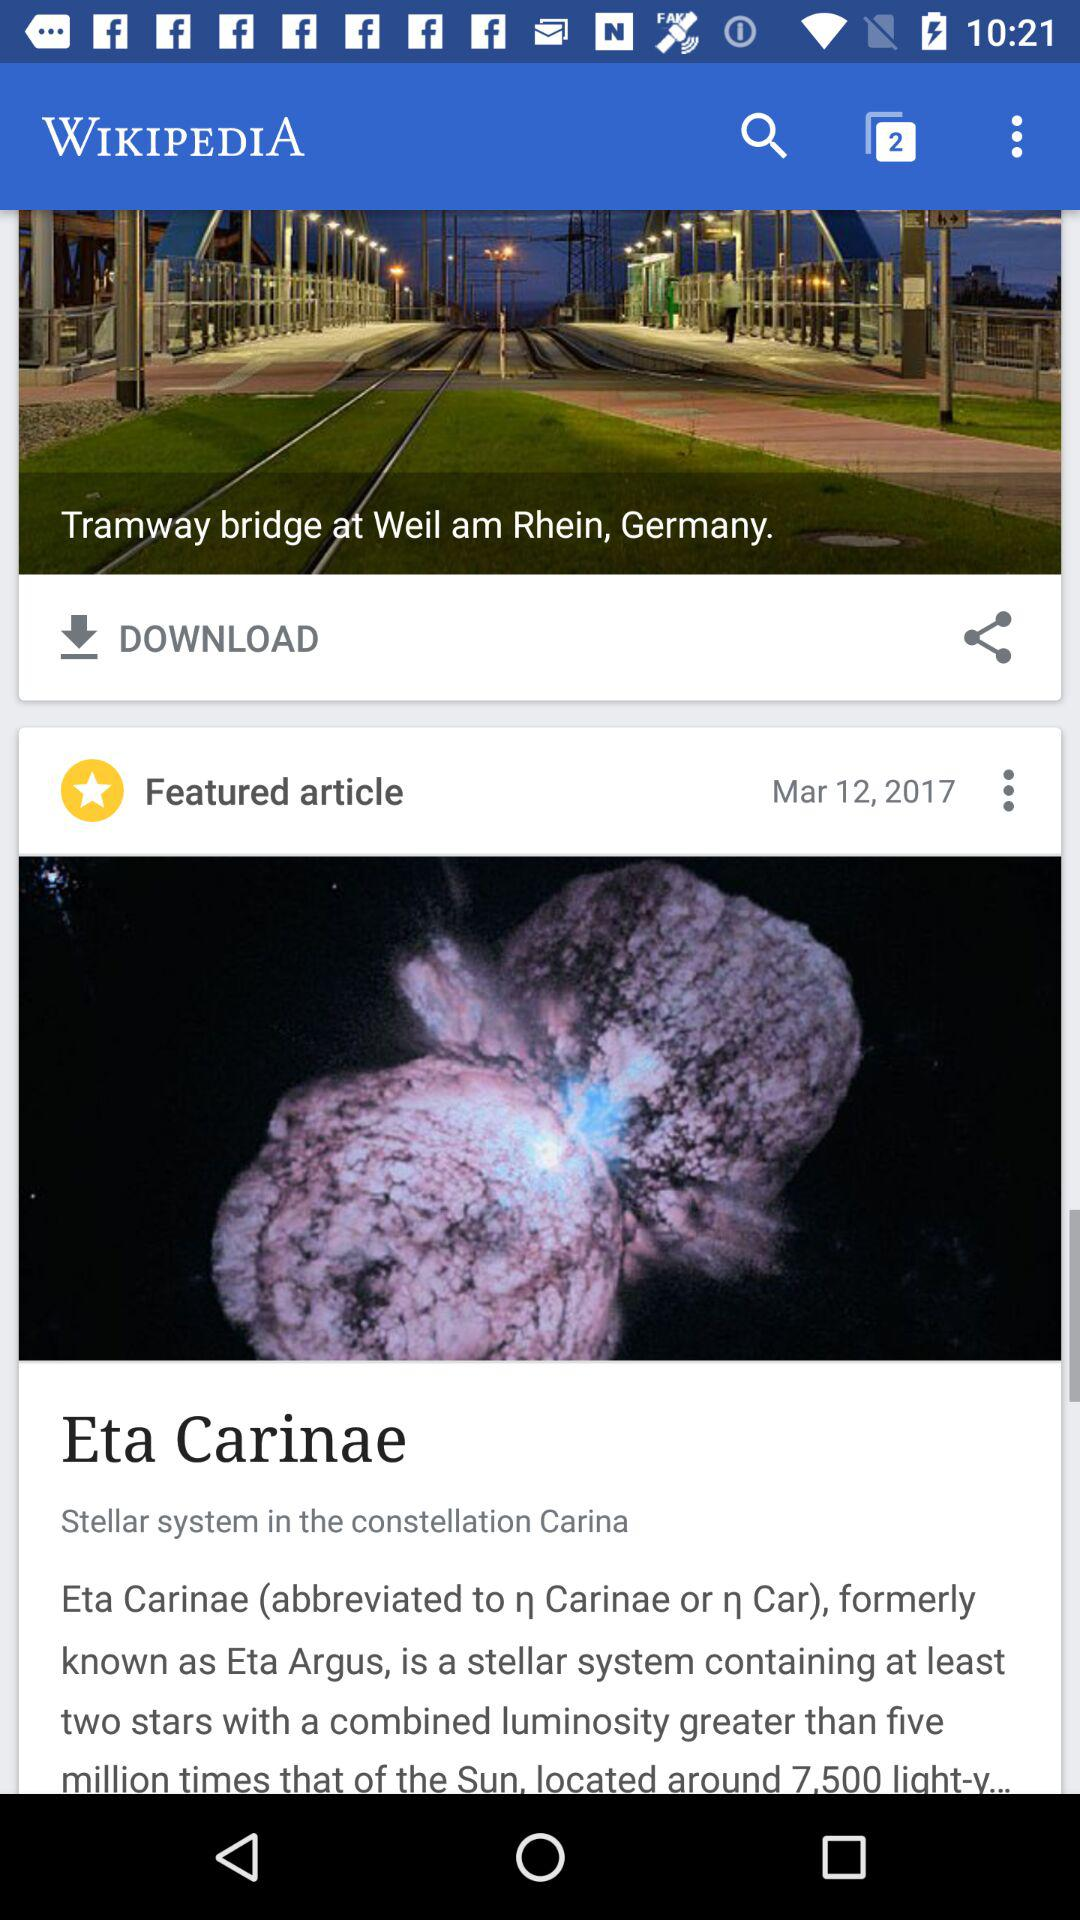What is the location? The location is the Tramway Bridge at Weil am Rhein, Germany. 